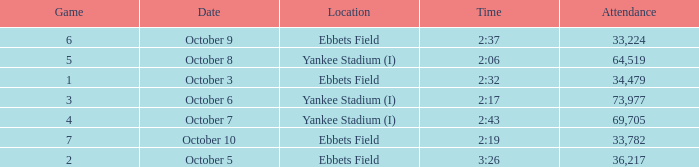What is the location of the game that has a number smaller than 2? Ebbets Field. 